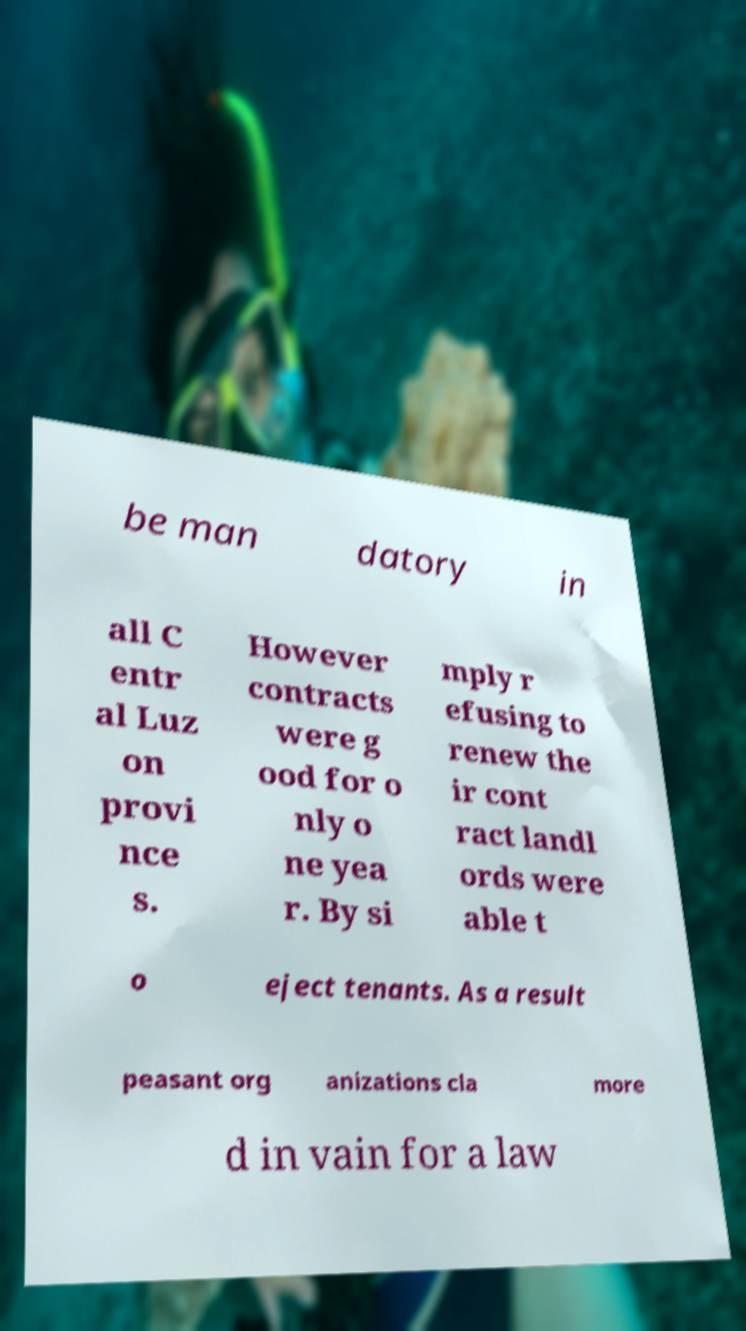There's text embedded in this image that I need extracted. Can you transcribe it verbatim? be man datory in all C entr al Luz on provi nce s. However contracts were g ood for o nly o ne yea r. By si mply r efusing to renew the ir cont ract landl ords were able t o eject tenants. As a result peasant org anizations cla more d in vain for a law 